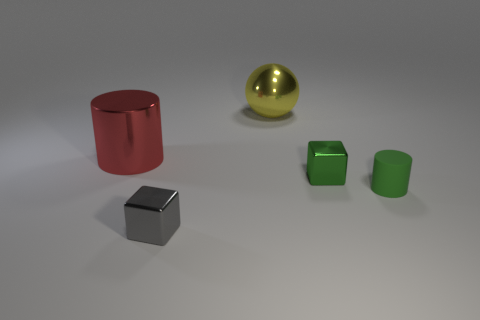Is the number of red rubber cylinders less than the number of large metal cylinders?
Provide a succinct answer. Yes. What number of other objects are there of the same material as the big yellow object?
Keep it short and to the point. 3. There is another thing that is the same shape as the green matte object; what is its size?
Your response must be concise. Large. Do the large object in front of the yellow sphere and the tiny green object that is left of the small matte thing have the same material?
Keep it short and to the point. Yes. Is the number of tiny green shiny blocks behind the green matte object less than the number of red matte things?
Provide a short and direct response. No. Is there any other thing that is the same shape as the red object?
Your answer should be very brief. Yes. What is the color of the small matte thing that is the same shape as the big red shiny thing?
Your answer should be very brief. Green. Do the metallic object in front of the matte thing and the small green metal object have the same size?
Your answer should be very brief. Yes. What size is the cylinder that is left of the metal object in front of the small green cylinder?
Make the answer very short. Large. Is the material of the ball the same as the cylinder that is in front of the big red cylinder?
Keep it short and to the point. No. 